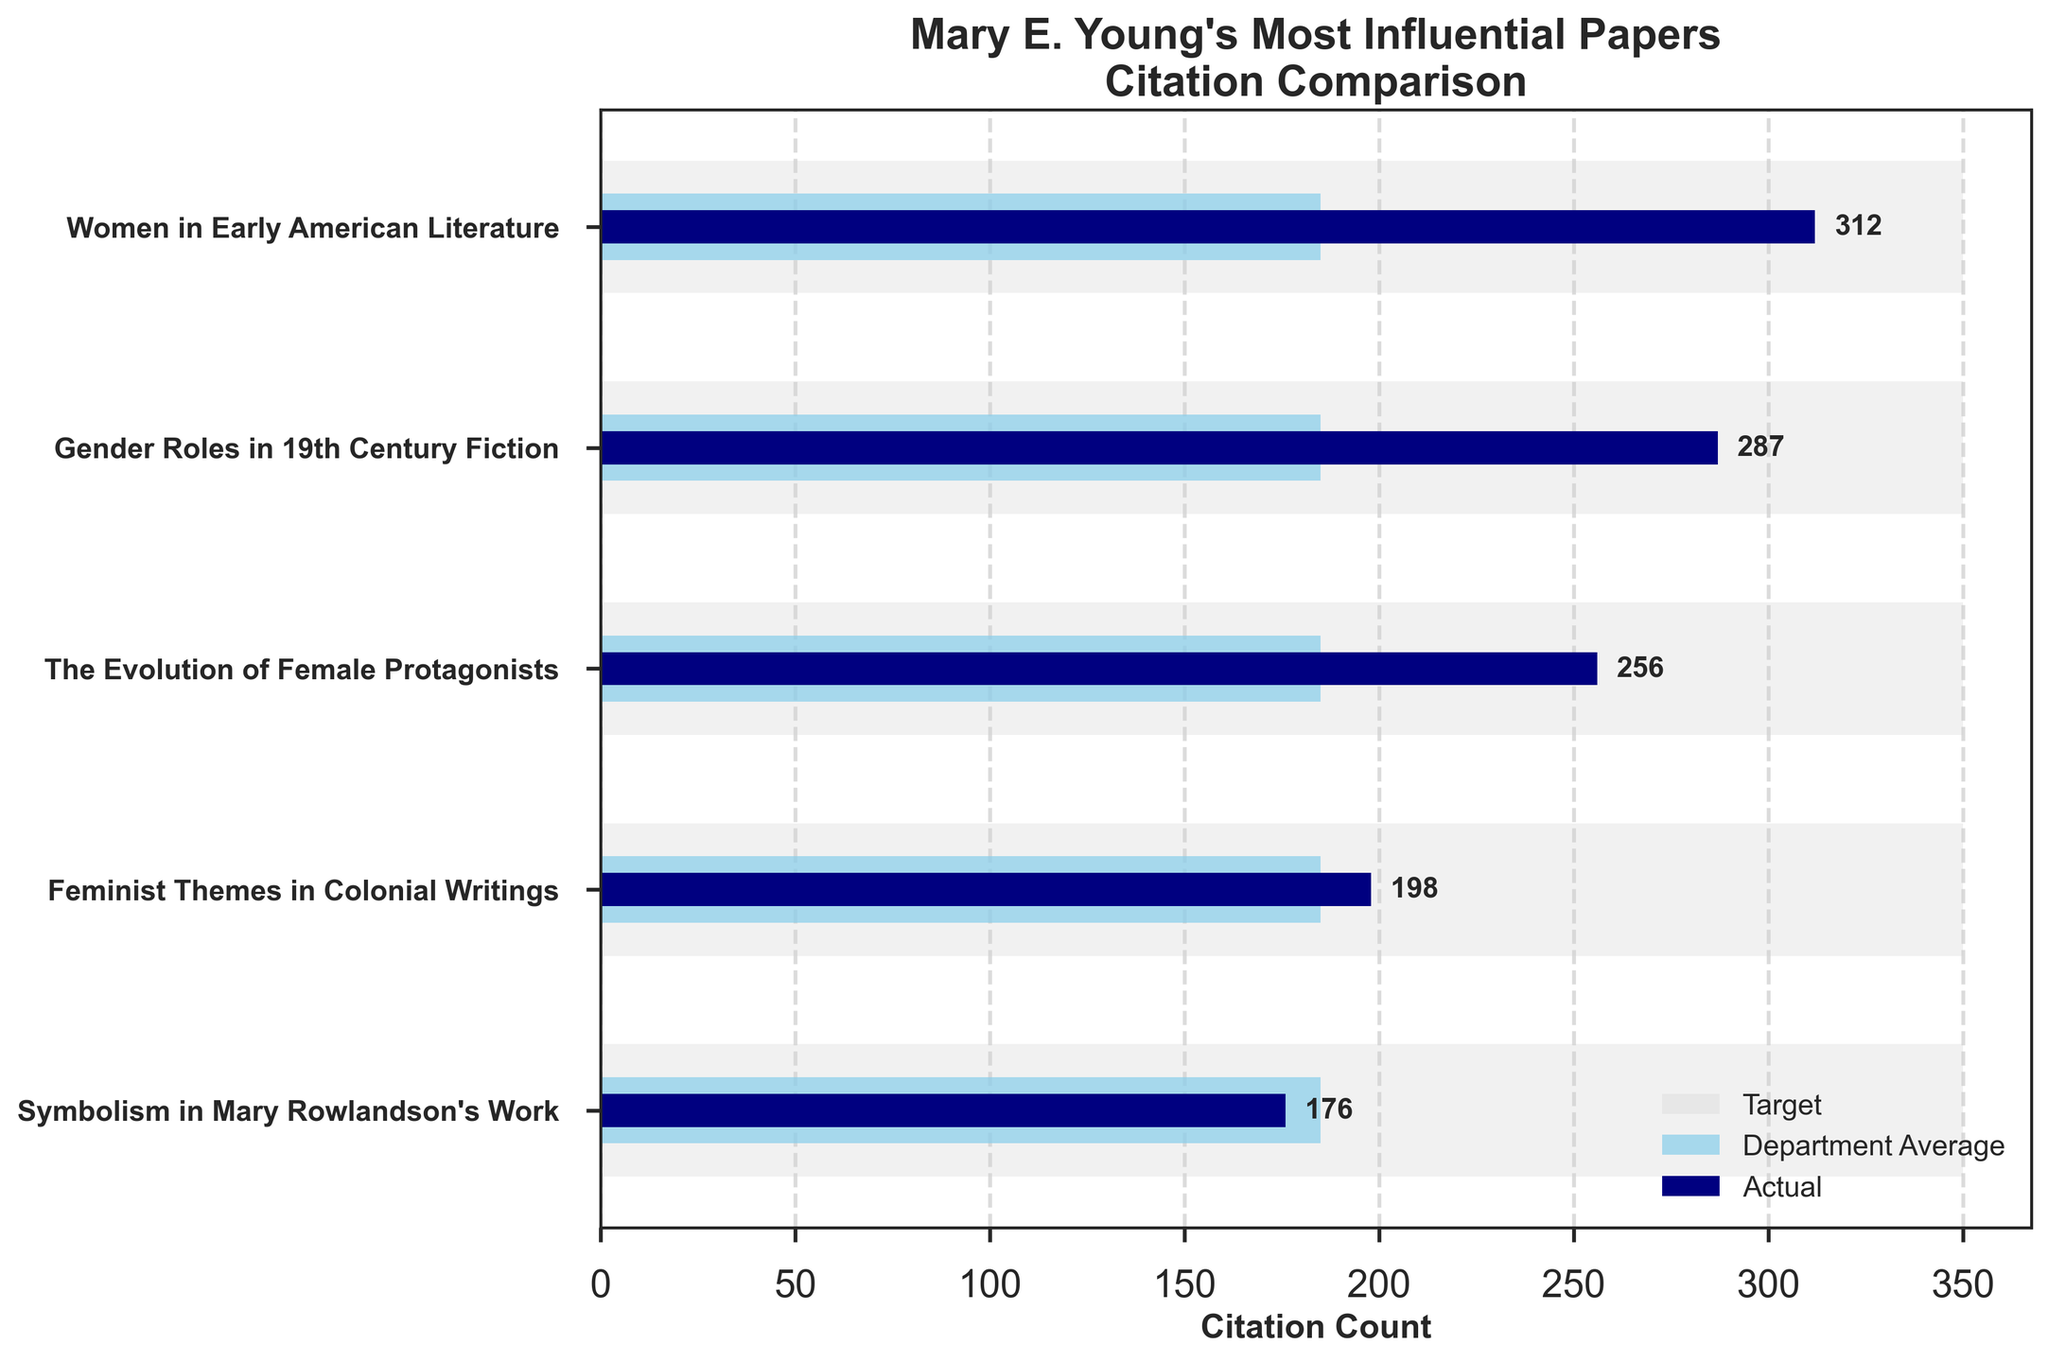What is the title of the figure? The title of the figure is usually found at the top of the plot and describes what the plot is about. In this case, the title is "Mary E. Young's Most Influential Papers Citation Comparison"
Answer: Mary E. Young's Most Influential Papers Citation Comparison What is the target citation count for "The Evolution of Female Protagonists"? Locate "The Evolution of Female Protagonists" on the y-axis, then look for the grey bar next to it, which represents the target citation count. The length of the grey bar is 350.
Answer: 350 Which paper has the highest actual citation count? Compare the navy bars for each paper. "Women in Early American Literature" has the longest navy bar, indicating the highest actual citation count of 312.
Answer: Women in Early American Literature What is the average comparative citation count of all the papers? Sum the comparative citation counts and divide by the number of papers: (185 + 185 + 185 + 185 + 185)/5 = 925/5 = 185.
Answer: 185 How much below the target citation count is "Feminist Themes in Colonial Writings"? The target for "Feminist Themes in Colonial Writings" is 350, and the actual count is 198. The difference is 350 - 198 = 152 below the target.
Answer: 152 Which paper performs closest to the department average? Compare the navy bars (actuals) to the skyblue bars (comparative). "Symbolism in Mary Rowlandson's Work" has an actual count (176) closest to the comparative count of 185, with a difference of 9.
Answer: Symbolism in Mary Rowlandson's Work How many papers meet or exceed the department average citation count? Compare the actual citation counts (navy bars) to the department average (skyblue bars). Three papers exceed the department average: "Women in Early American Literature", "Gender Roles in 19th Century Fiction", and "The Evolution of Female Protagonists".
Answer: 3 Which paper has the smallest gap between actual and target citation counts? Compare the differences between actual and target counts for each paper. "Women in Early American Literature" has the smallest gap: 350 - 312 = 38.
Answer: Women in Early American Literature How many papers are listed in the figure? The number of papers corresponds to the number of bars along the y-axis. There are 5 titles listed, so there are 5 papers.
Answer: 5 What is the difference in actual citation counts between "Gender Roles in 19th Century Fiction" and "Symbolism in Mary Rowlandson's Work"? Subtract the actual count of "Symbolism in Mary Rowlandson's Work" (176) from that of "Gender Roles in 19th Century Fiction" (287): 287 - 176 = 111.
Answer: 111 